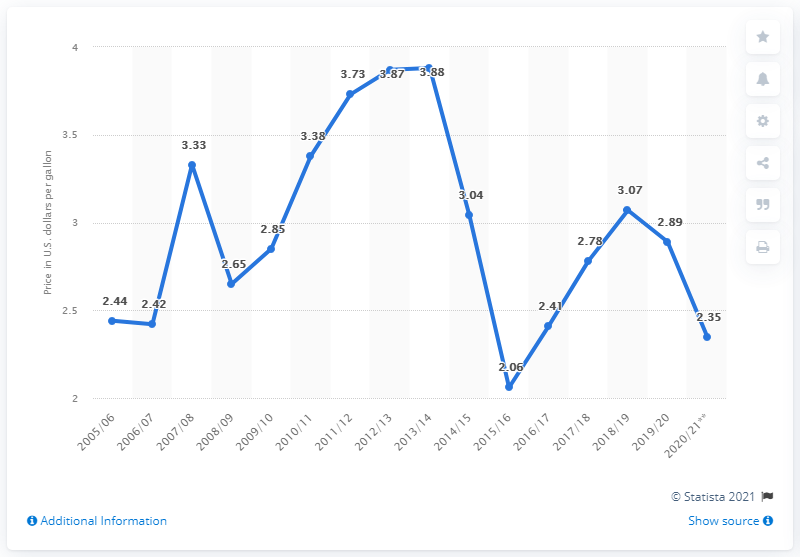Mention a couple of crucial points in this snapshot. In 2020/21, the average price of heating oil in the United States was $2.35 per gallon, with an average price of $2.35 being paid for each gallon of heating oil in the United States during that time period. 